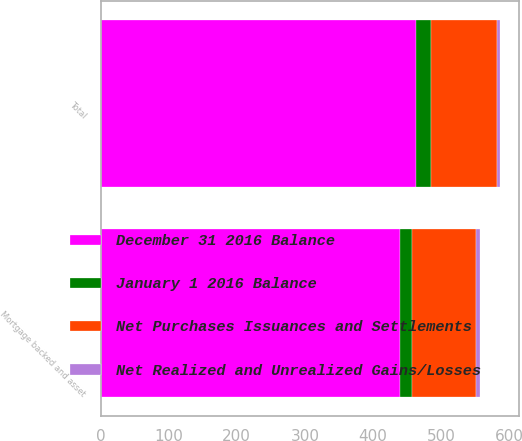Convert chart to OTSL. <chart><loc_0><loc_0><loc_500><loc_500><stacked_bar_chart><ecel><fcel>Mortgage backed and asset<fcel>Total<nl><fcel>December 31 2016 Balance<fcel>440<fcel>464<nl><fcel>Net Realized and Unrealized Gains/Losses<fcel>7<fcel>4<nl><fcel>Net Purchases Issuances and Settlements<fcel>93<fcel>97<nl><fcel>January 1 2016 Balance<fcel>18<fcel>21<nl></chart> 